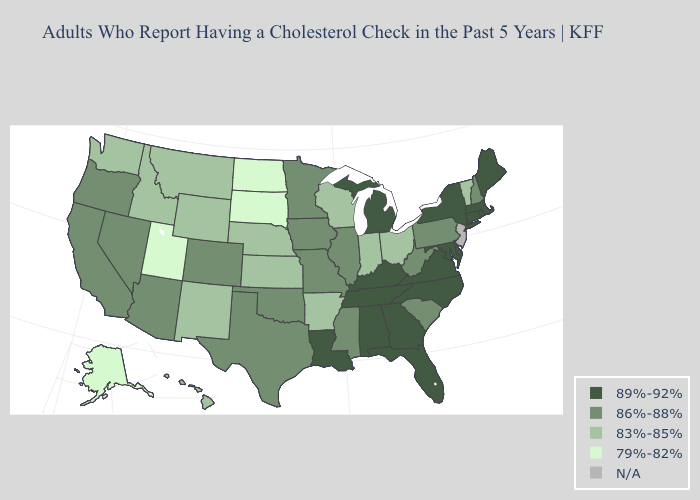What is the value of Oregon?
Give a very brief answer. 86%-88%. What is the highest value in the USA?
Concise answer only. 89%-92%. Which states have the lowest value in the South?
Write a very short answer. Arkansas. What is the lowest value in the Northeast?
Give a very brief answer. 83%-85%. Among the states that border Indiana , does Kentucky have the highest value?
Be succinct. Yes. Is the legend a continuous bar?
Give a very brief answer. No. Is the legend a continuous bar?
Be succinct. No. What is the value of Tennessee?
Quick response, please. 89%-92%. Does South Carolina have the highest value in the South?
Give a very brief answer. No. What is the value of Georgia?
Answer briefly. 89%-92%. Name the states that have a value in the range 79%-82%?
Write a very short answer. Alaska, North Dakota, South Dakota, Utah. What is the lowest value in states that border Massachusetts?
Answer briefly. 83%-85%. What is the value of Nebraska?
Write a very short answer. 83%-85%. Name the states that have a value in the range 86%-88%?
Keep it brief. Arizona, California, Colorado, Illinois, Iowa, Minnesota, Mississippi, Missouri, Nevada, New Hampshire, Oklahoma, Oregon, Pennsylvania, South Carolina, Texas, West Virginia. Does the first symbol in the legend represent the smallest category?
Give a very brief answer. No. 